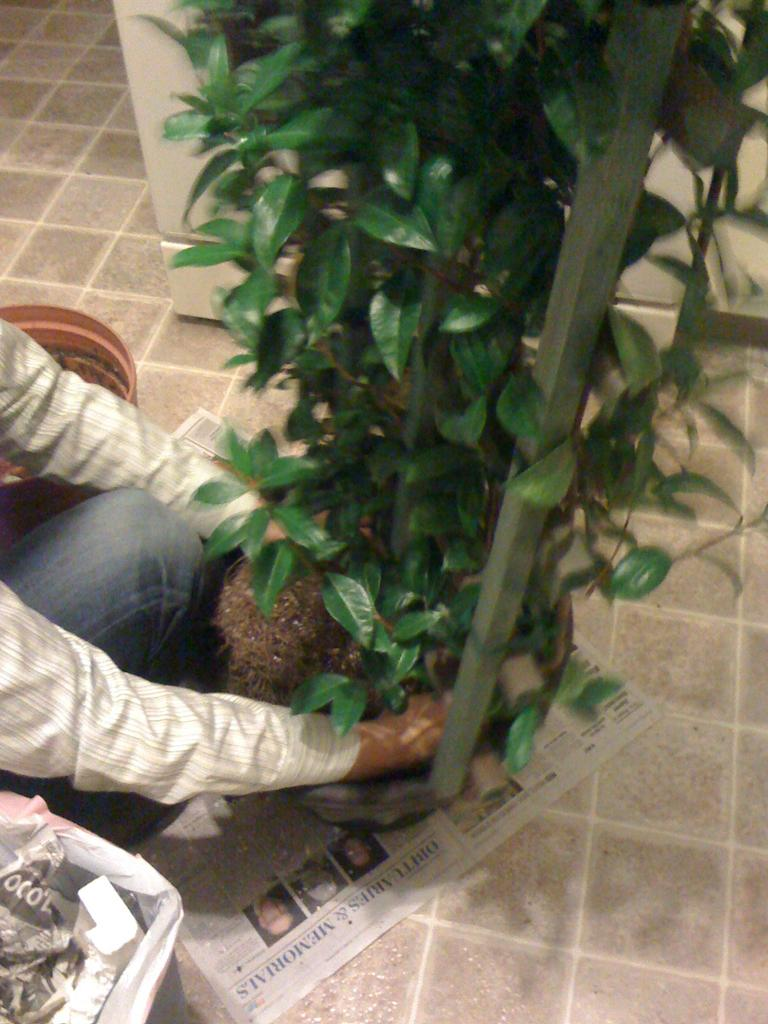What is the main object in the image? There is a newspaper in the image. What type of natural elements can be seen in the image? There are trees in the image. How many people are present in the image? There is one person in the image. What type of flooring is visible at the bottom of the image? Tiles are visible at the bottom of the image. What type of brass instrument is the person playing in the image? There is no brass instrument or any indication of music playing in the image. 